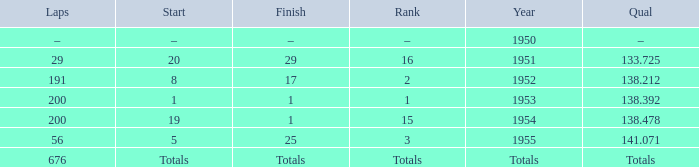What ranking that had a start of 19? 15.0. 